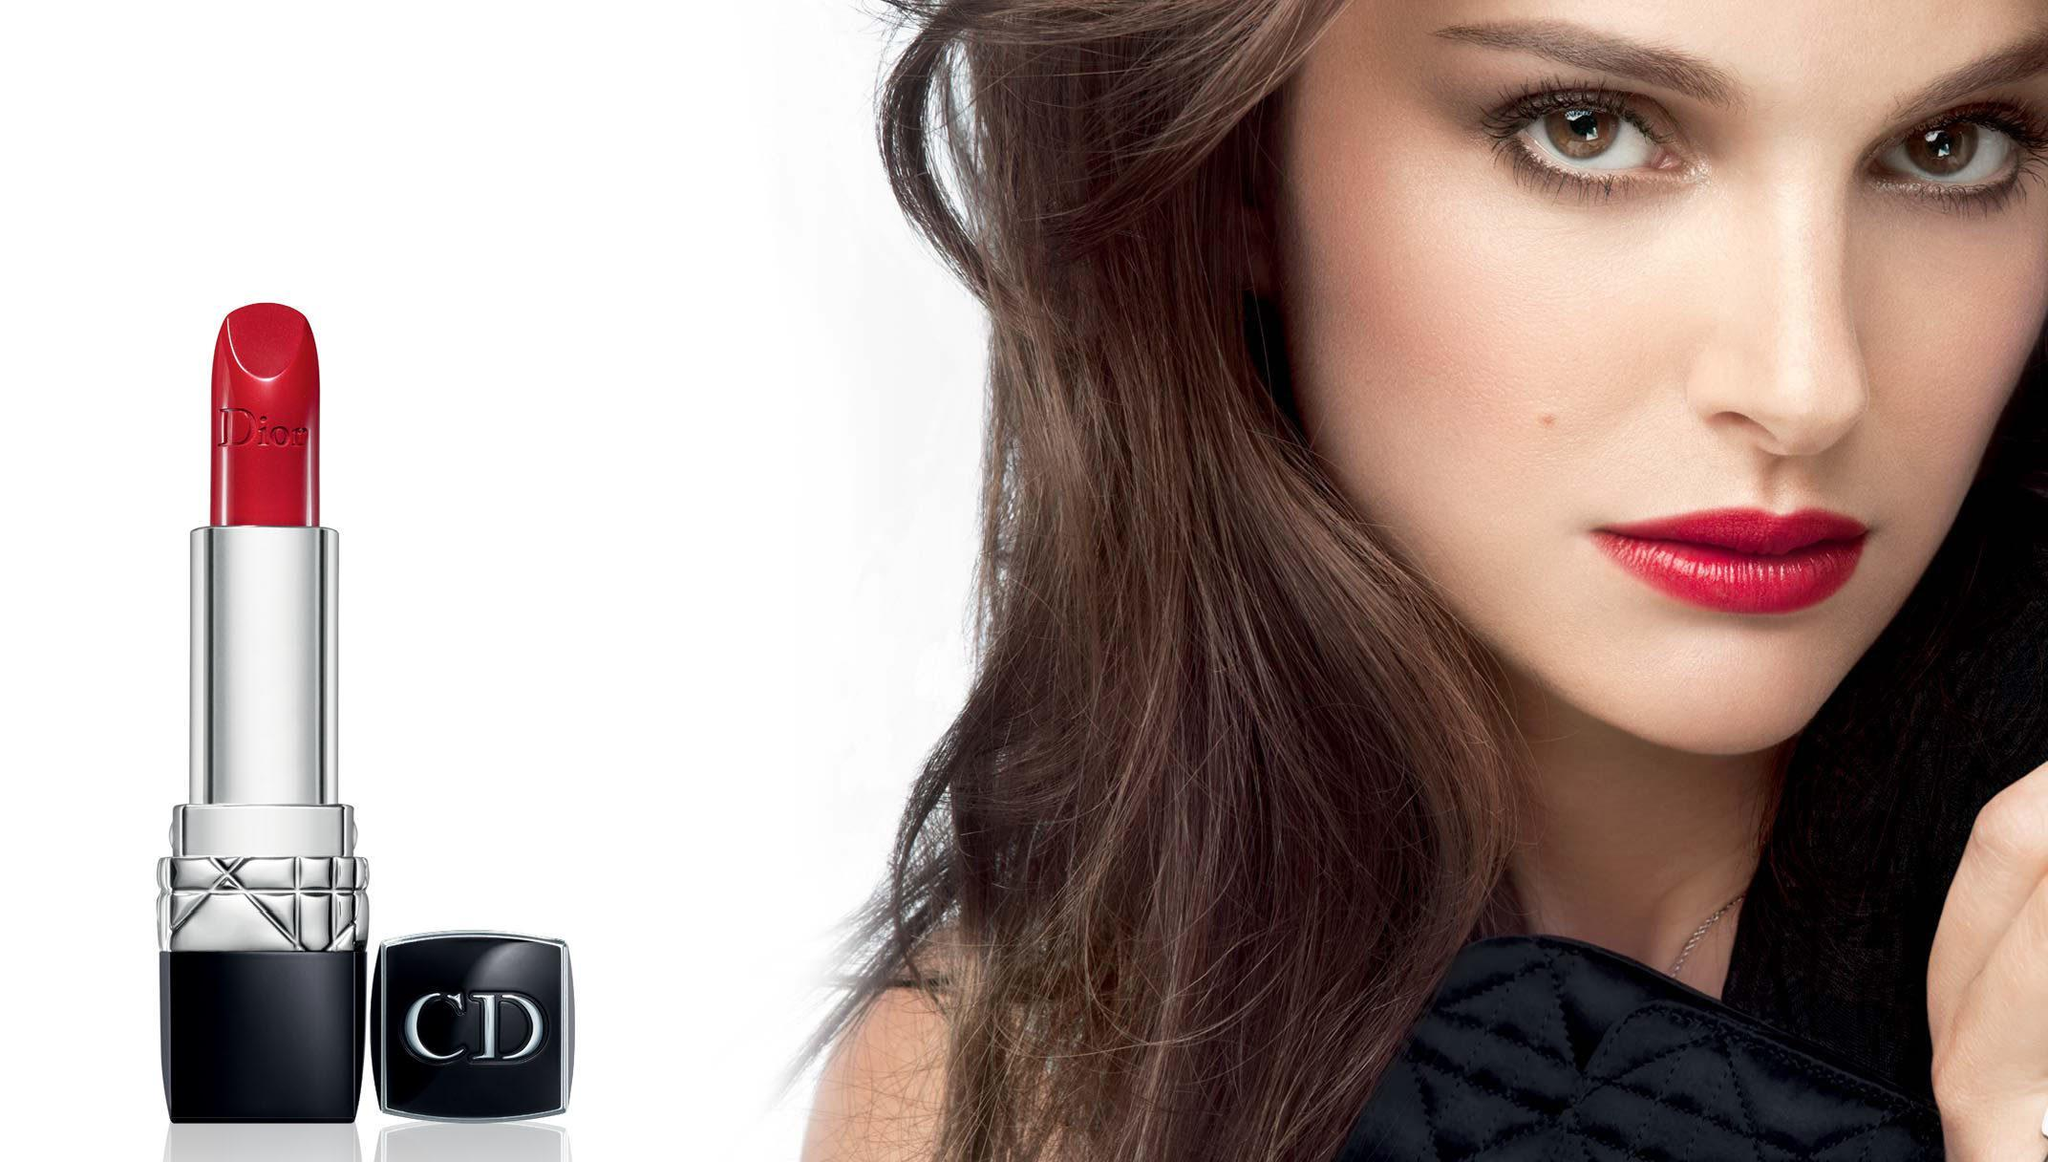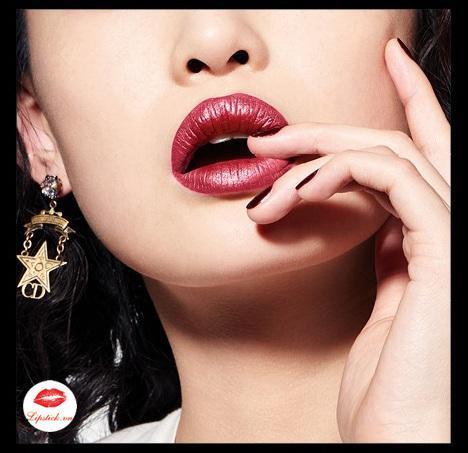The first image is the image on the left, the second image is the image on the right. Analyze the images presented: Is the assertion "The woman in one of the images has her hand near her chin." valid? Answer yes or no. Yes. 